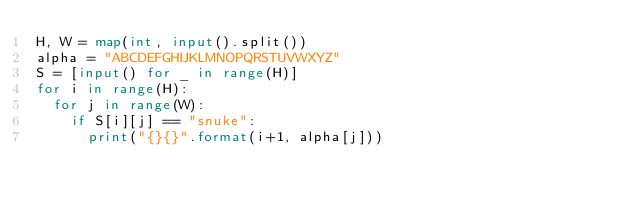<code> <loc_0><loc_0><loc_500><loc_500><_Python_>H, W = map(int, input().split())
alpha = "ABCDEFGHIJKLMNOPQRSTUVWXYZ"
S = [input() for _ in range(H)]
for i in range(H):
  for j in range(W):
    if S[i][j] == "snuke":
      print("{}{}".format(i+1, alpha[j]))</code> 